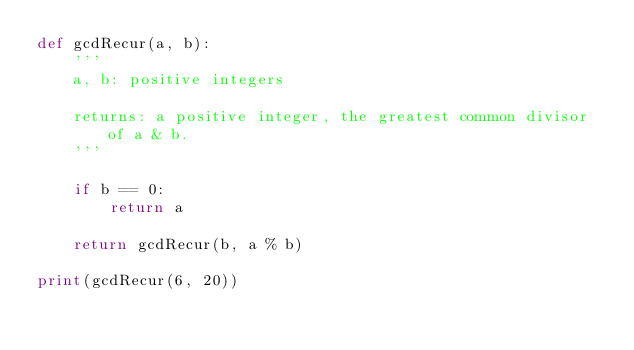Convert code to text. <code><loc_0><loc_0><loc_500><loc_500><_Python_>def gcdRecur(a, b):
    '''
    a, b: positive integers

    returns: a positive integer, the greatest common divisor of a & b.
    '''

    if b == 0:
        return a

    return gcdRecur(b, a % b)

print(gcdRecur(6, 20))
</code> 